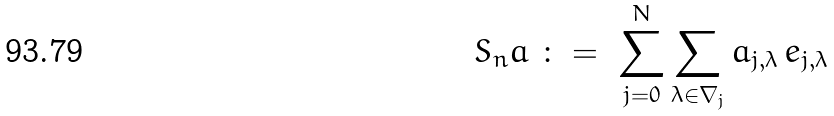<formula> <loc_0><loc_0><loc_500><loc_500>S _ { n } a \ \colon = \ \sum _ { j = 0 } ^ { N } \sum _ { \lambda \in \nabla _ { j } } a _ { j , \lambda } \, e _ { j , \lambda }</formula> 